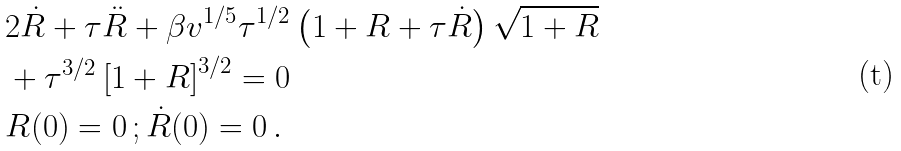<formula> <loc_0><loc_0><loc_500><loc_500>& 2 \dot { R } + \tau \ddot { R } + \beta v ^ { 1 / 5 } \tau ^ { 1 / 2 } \left ( 1 + R + \tau \dot { R } \right ) \sqrt { 1 + R } \\ & + \tau ^ { 3 / 2 } \left [ 1 + R \right ] ^ { 3 / 2 } = 0 \\ & R ( 0 ) = 0 \, ; \dot { R } ( 0 ) = 0 \, .</formula> 